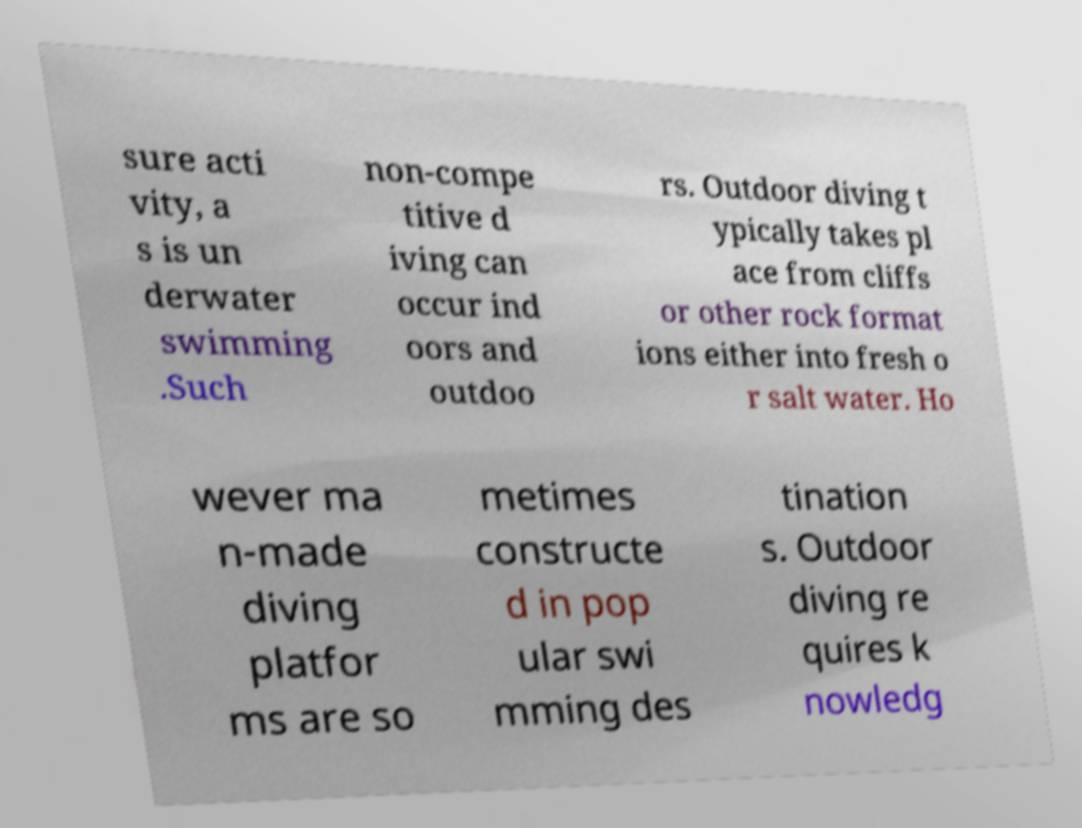I need the written content from this picture converted into text. Can you do that? sure acti vity, a s is un derwater swimming .Such non-compe titive d iving can occur ind oors and outdoo rs. Outdoor diving t ypically takes pl ace from cliffs or other rock format ions either into fresh o r salt water. Ho wever ma n-made diving platfor ms are so metimes constructe d in pop ular swi mming des tination s. Outdoor diving re quires k nowledg 